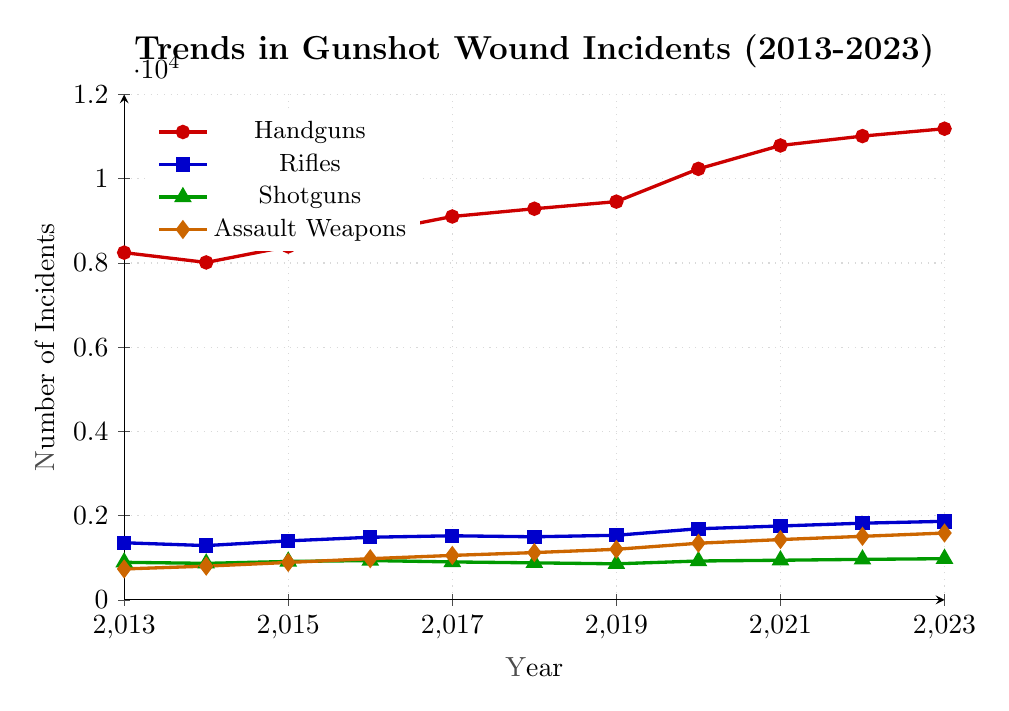what year had the highest number of gunshot wound incidents involving handguns? Locate the line representing handguns (red) on the chart. Follow the red line to the highest point and then look at the corresponding year on the x-axis.
Answer: 2023 which firearm type saw the largest increase in incidents from 2013 to 2023? Compare the starting point (2013) and the end point (2023) for each firearm type. Calculate the difference for each: 
Handguns: 11187 - 8245 = 2942
Rifles: 1865 - 1356 = 509
Shotguns: 978 - 892 = 86
Assault Weapons: 1587 - 734 = 853
The largest increase is with Handguns.
Answer: Handguns how many gunshot wound incidents involved shotguns in 2020 compared to 2015? Locate the green line representing shotguns on the chart. Compare the values from 2020 and 2015:
2020: 923
2015: 912
Answer: 923 and 912 by how much did the number of rifle-related incidents change from 2018 to 2023? Find the blue line for rifles and compare the values for the years 2018 and 2023:
2023: 1865
2018: 1498
Subtract the two values: 1865 - 1498 = 367
Answer: 367 which year showed the smallest number of incidents involving assault weapons? Look at the line for assault weapons (orange) and find the lowest point on the chart, then determine the corresponding year on the x-axis.
Answer: 2013 what is the average number of handgun-related incidents over the decade? Add up all the handgun-related incidents for each year and then divide by the number of years:
(8245 + 8012 + 8392 + 8721 + 9103 + 9287 + 9456 + 10234 + 10789 + 11012 + 11187) / 11
(103438) / 11 = 9403.3
Answer: 9403.3 how did the number of shotgun-related incidents change between 2017 and 2018? Observe the green line from 2017 (901) to 2018 (879):
2017: 901
2018: 879
Calculate the difference:  901 - 879 = 22
Answer: Decreased by 22 in which year did the number of rifle-related incidents surpass 1500? Find the blue line representing rifles and look for the year when the value first exceeded 1500:
2017: 1522
Answer: 2017 